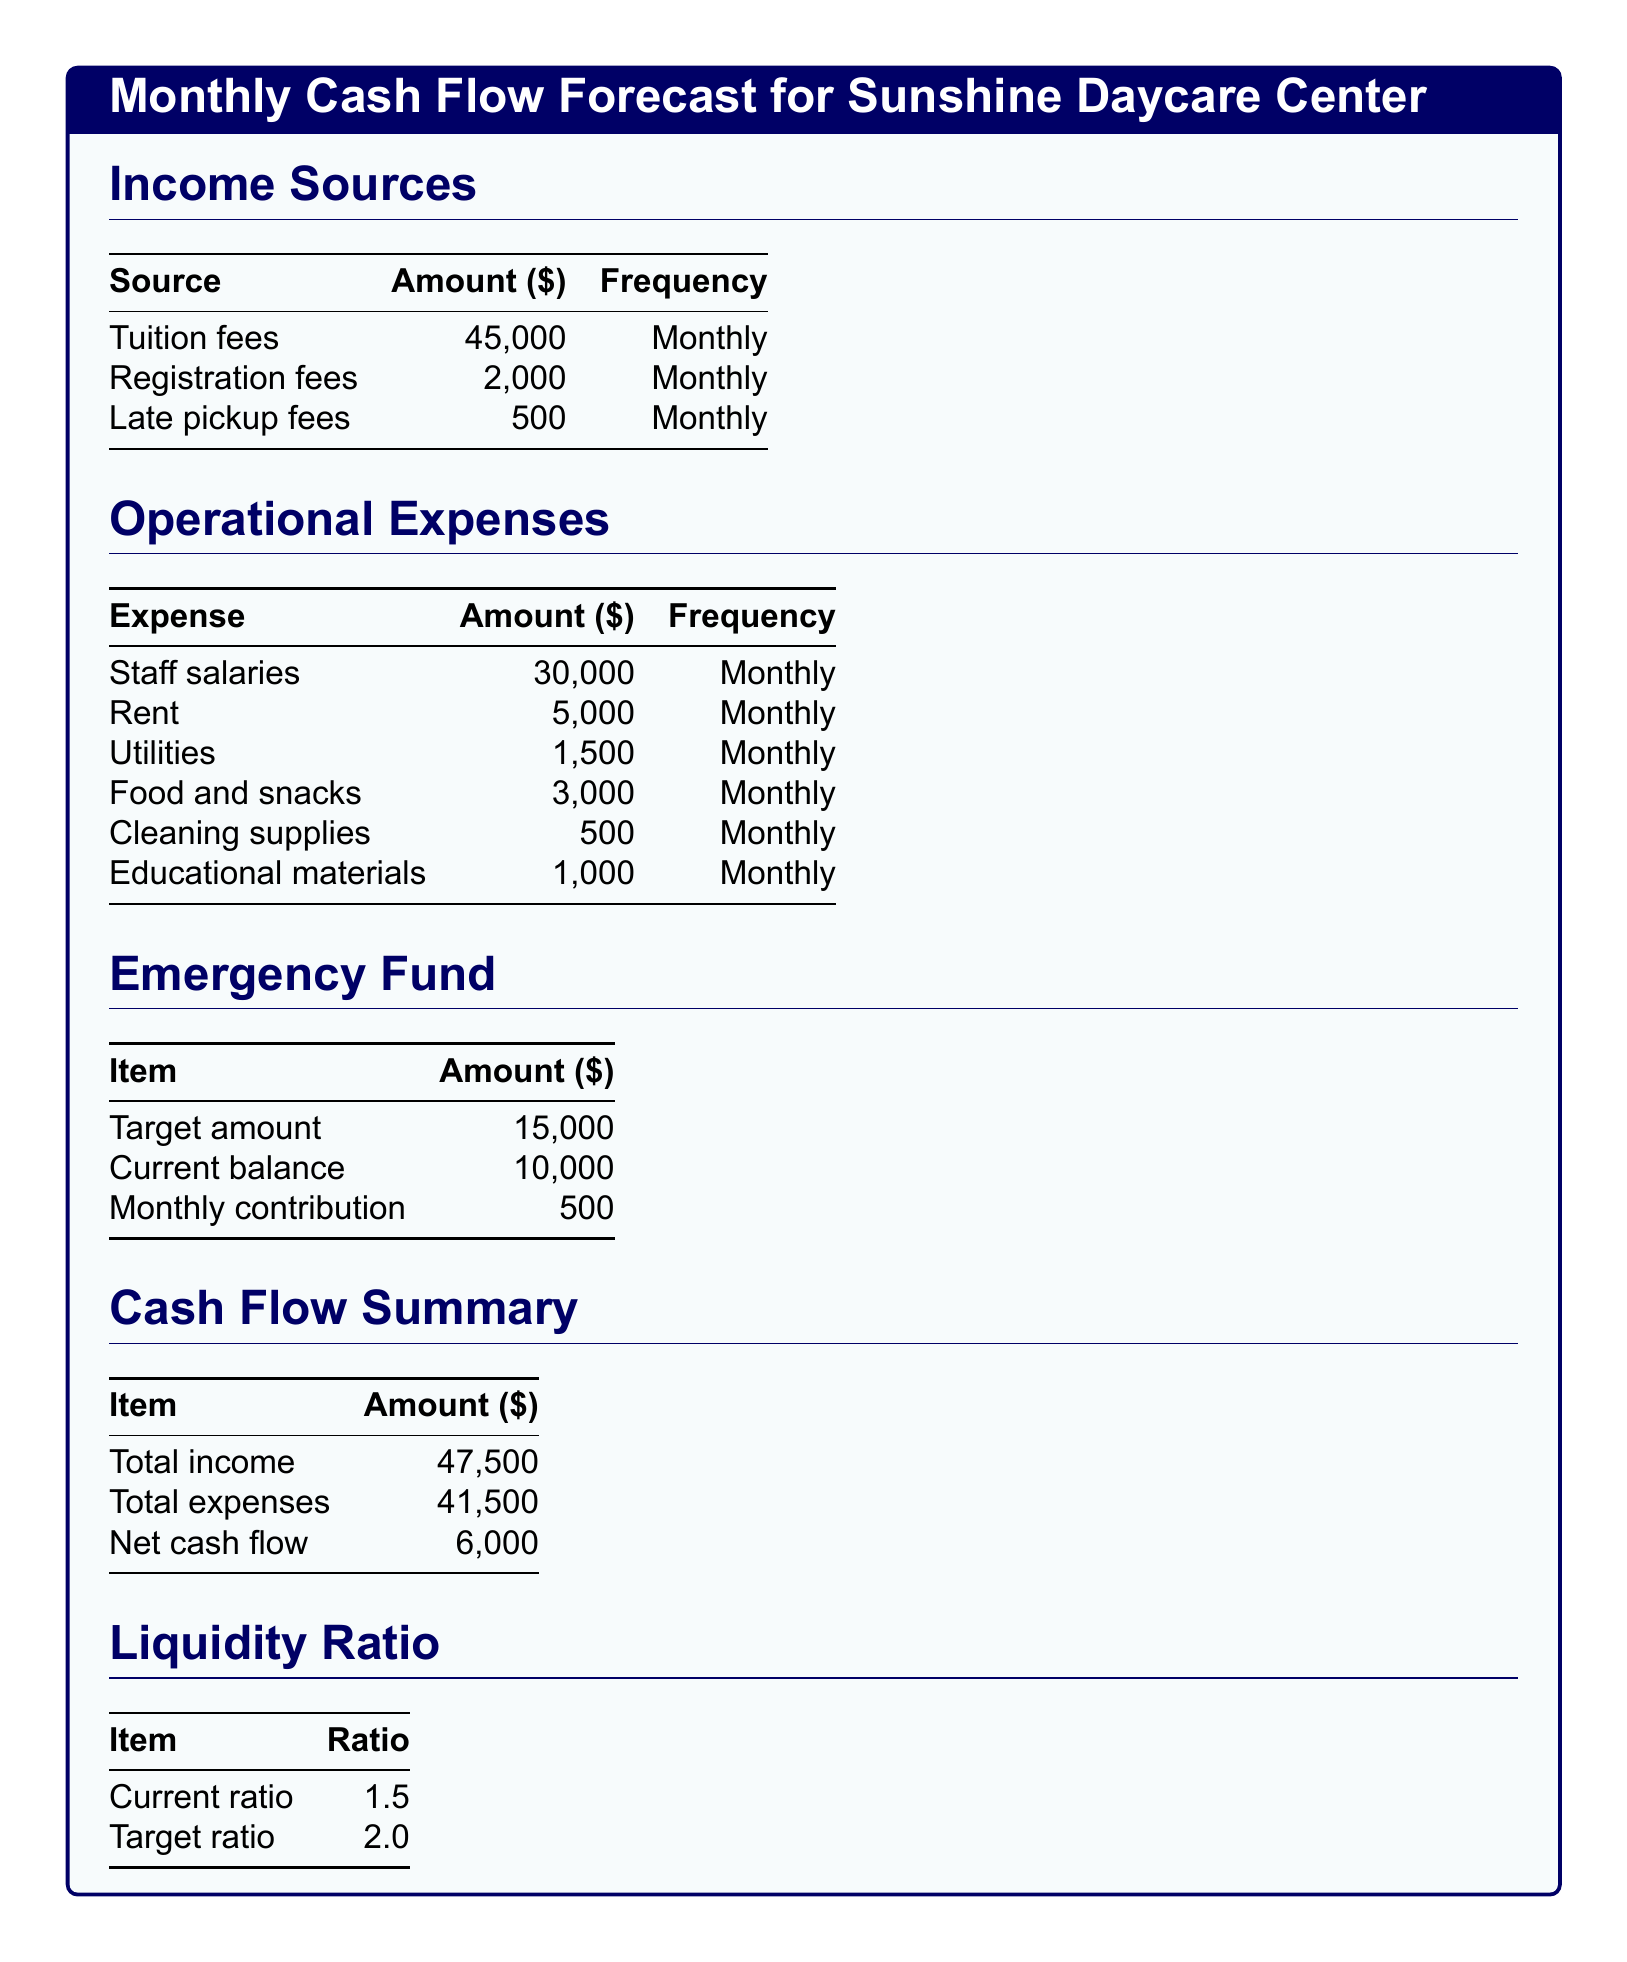What is the total income? The total income is the sum of all income sources: $45,000 + $2,000 + $500 = $47,500.
Answer: $47,500 What are the monthly utilities expenses? The monthly utilities expenses listed in the document is $1,500.
Answer: $1,500 What is the current balance of the emergency fund? The current balance of the emergency fund is explicitly stated as $10,000.
Answer: $10,000 What is the monthly contribution to the emergency fund? The document states that the monthly contribution to the emergency fund is $500.
Answer: $500 What is the net cash flow? The net cash flow is calculated by subtracting total expenses from total income: $47,500 - $41,500 = $6,000.
Answer: $6,000 What is the target liquidity ratio? The target liquidity ratio specified in the document is 2.0.
Answer: 2.0 What is the total amount allocated for staff salaries? The staff salaries amount stated in the document is $30,000.
Answer: $30,000 How much is collected from late pickup fees? The document indicates that late pickup fees amount to $500.
Answer: $500 What is the target amount for the emergency fund? The target amount for the emergency fund is mentioned as $15,000.
Answer: $15,000 What is the total operational expenses? The total operational expenses are calculated as $30,000 + $5,000 + $1,500 + $3,000 + $500 + $1,000 = $41,500.
Answer: $41,500 